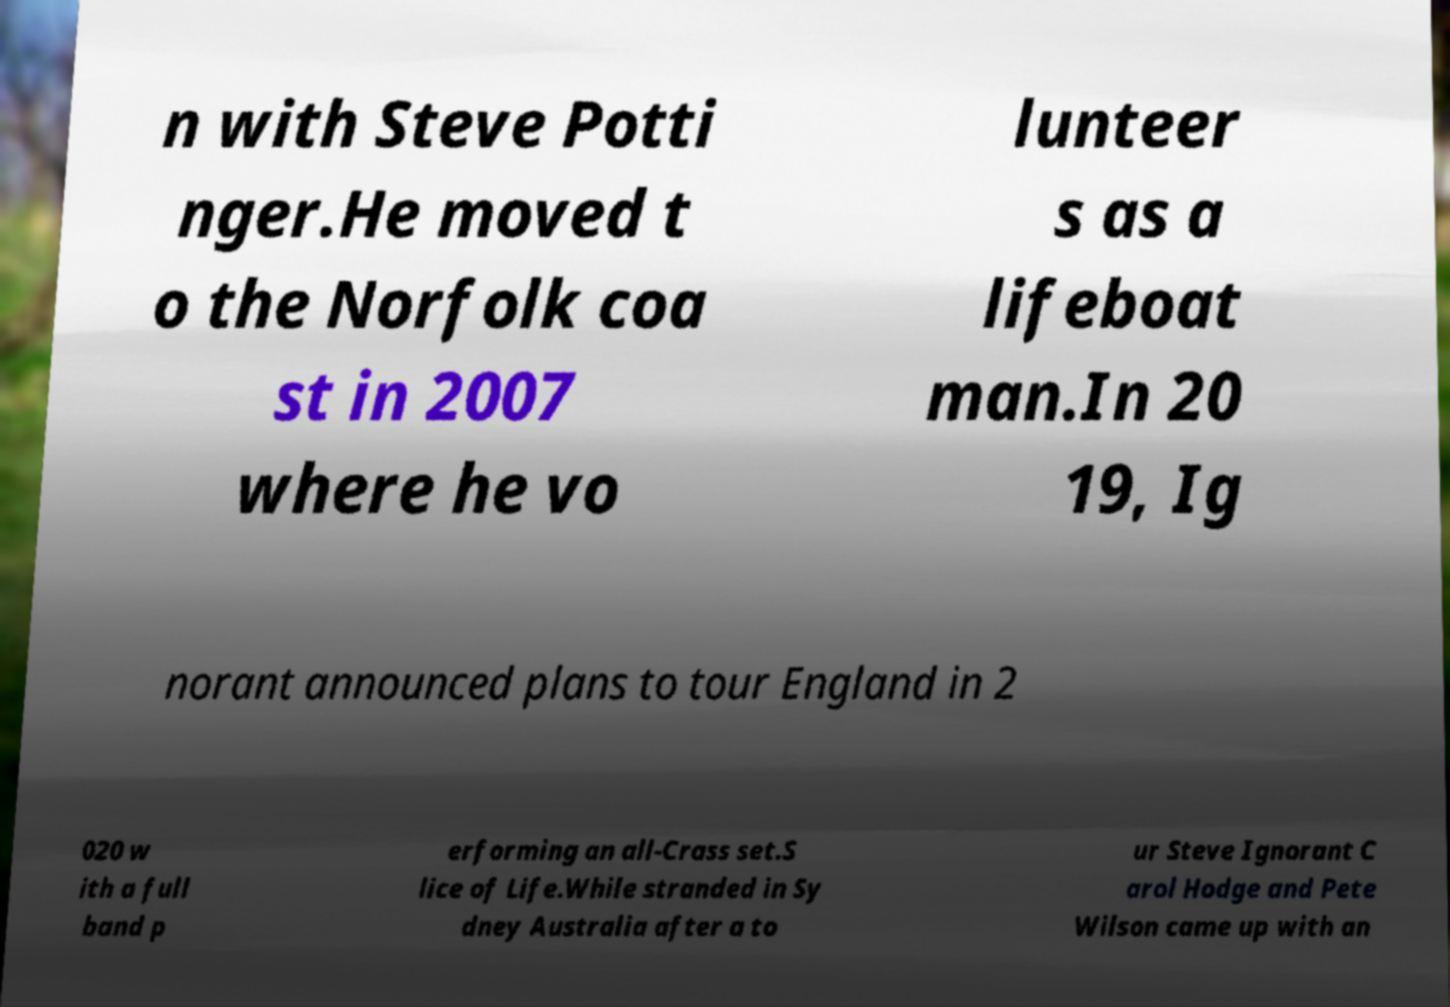Could you extract and type out the text from this image? n with Steve Potti nger.He moved t o the Norfolk coa st in 2007 where he vo lunteer s as a lifeboat man.In 20 19, Ig norant announced plans to tour England in 2 020 w ith a full band p erforming an all-Crass set.S lice of Life.While stranded in Sy dney Australia after a to ur Steve Ignorant C arol Hodge and Pete Wilson came up with an 